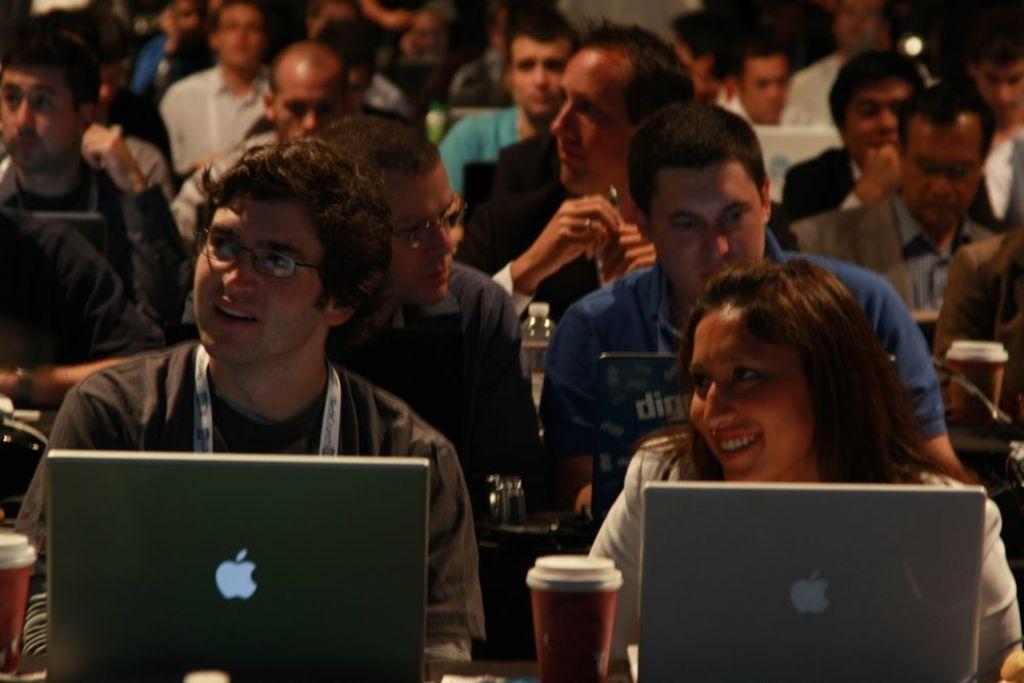Can you describe this image briefly? In the image in the center we can see two people were sitting on the chair and they were smiling,which we can see on their faces. In front of them,there is a table. On the table,we can see glasses and laptops. In the background we can see few people were sitting. 